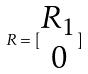Convert formula to latex. <formula><loc_0><loc_0><loc_500><loc_500>R = [ \begin{matrix} R _ { 1 } \\ 0 \end{matrix} ]</formula> 